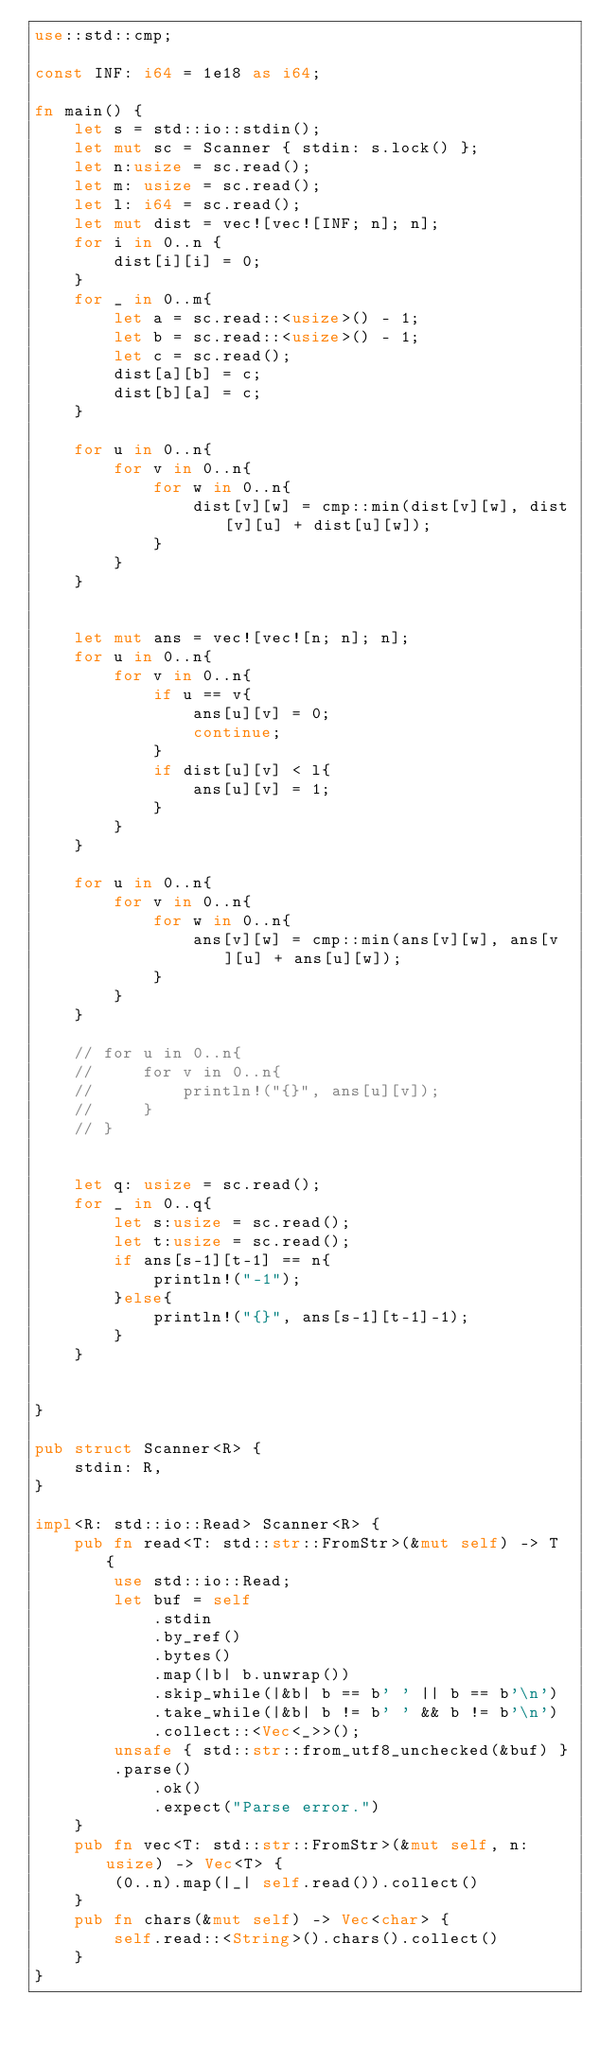<code> <loc_0><loc_0><loc_500><loc_500><_Rust_>use::std::cmp;

const INF: i64 = 1e18 as i64;

fn main() {
    let s = std::io::stdin();
    let mut sc = Scanner { stdin: s.lock() };
    let n:usize = sc.read();
    let m: usize = sc.read();
    let l: i64 = sc.read();
    let mut dist = vec![vec![INF; n]; n];
    for i in 0..n {
        dist[i][i] = 0;
    }
    for _ in 0..m{
        let a = sc.read::<usize>() - 1;
        let b = sc.read::<usize>() - 1;
        let c = sc.read();
        dist[a][b] = c;
        dist[b][a] = c;
    }

    for u in 0..n{
        for v in 0..n{
            for w in 0..n{
                dist[v][w] = cmp::min(dist[v][w], dist[v][u] + dist[u][w]);
            }
        }
    }

    
    let mut ans = vec![vec![n; n]; n];
    for u in 0..n{
        for v in 0..n{
            if u == v{
                ans[u][v] = 0;
                continue;
            }
            if dist[u][v] < l{
                ans[u][v] = 1;
            }
        }
    }
    
    for u in 0..n{
        for v in 0..n{
            for w in 0..n{
                ans[v][w] = cmp::min(ans[v][w], ans[v][u] + ans[u][w]);
            }
        }
    }

    // for u in 0..n{
    //     for v in 0..n{
    //         println!("{}", ans[u][v]);
    //     }
    // }


    let q: usize = sc.read();
    for _ in 0..q{
        let s:usize = sc.read();
        let t:usize = sc.read();
        if ans[s-1][t-1] == n{
            println!("-1");
        }else{
            println!("{}", ans[s-1][t-1]-1);
        }
    }
    
    
}

pub struct Scanner<R> {
    stdin: R,
}

impl<R: std::io::Read> Scanner<R> {
    pub fn read<T: std::str::FromStr>(&mut self) -> T {
        use std::io::Read;
        let buf = self
            .stdin
            .by_ref()
            .bytes()
            .map(|b| b.unwrap())
            .skip_while(|&b| b == b' ' || b == b'\n')
            .take_while(|&b| b != b' ' && b != b'\n')
            .collect::<Vec<_>>();
        unsafe { std::str::from_utf8_unchecked(&buf) }
        .parse()
            .ok()
            .expect("Parse error.")
    }
    pub fn vec<T: std::str::FromStr>(&mut self, n: usize) -> Vec<T> {
        (0..n).map(|_| self.read()).collect()
    }
    pub fn chars(&mut self) -> Vec<char> {
        self.read::<String>().chars().collect()
    }
}


</code> 